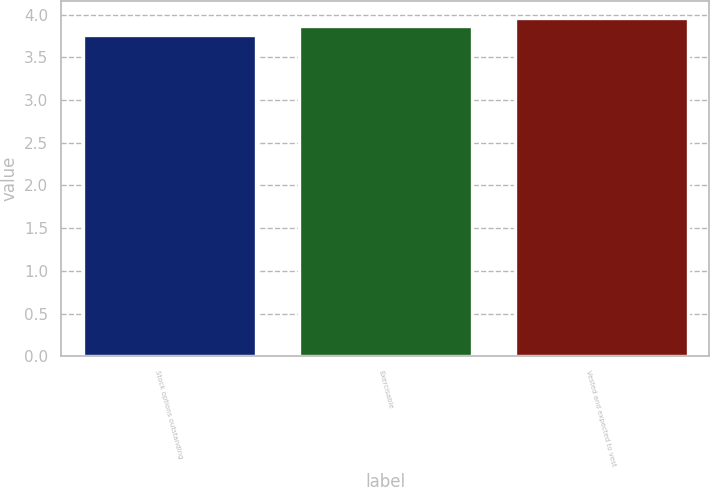<chart> <loc_0><loc_0><loc_500><loc_500><bar_chart><fcel>Stock options outstanding<fcel>Exercisable<fcel>Vested and expected to vest<nl><fcel>3.76<fcel>3.86<fcel>3.96<nl></chart> 